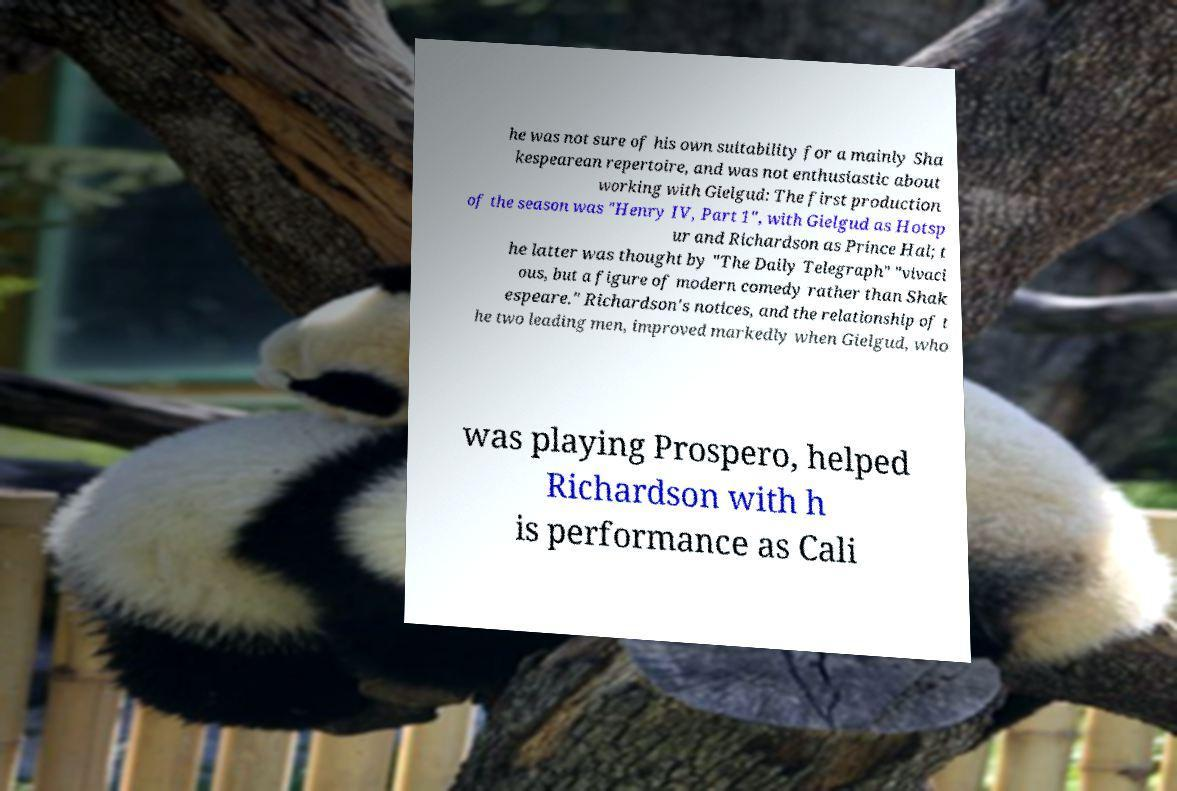There's text embedded in this image that I need extracted. Can you transcribe it verbatim? he was not sure of his own suitability for a mainly Sha kespearean repertoire, and was not enthusiastic about working with Gielgud: The first production of the season was "Henry IV, Part 1", with Gielgud as Hotsp ur and Richardson as Prince Hal; t he latter was thought by "The Daily Telegraph" "vivaci ous, but a figure of modern comedy rather than Shak espeare." Richardson's notices, and the relationship of t he two leading men, improved markedly when Gielgud, who was playing Prospero, helped Richardson with h is performance as Cali 